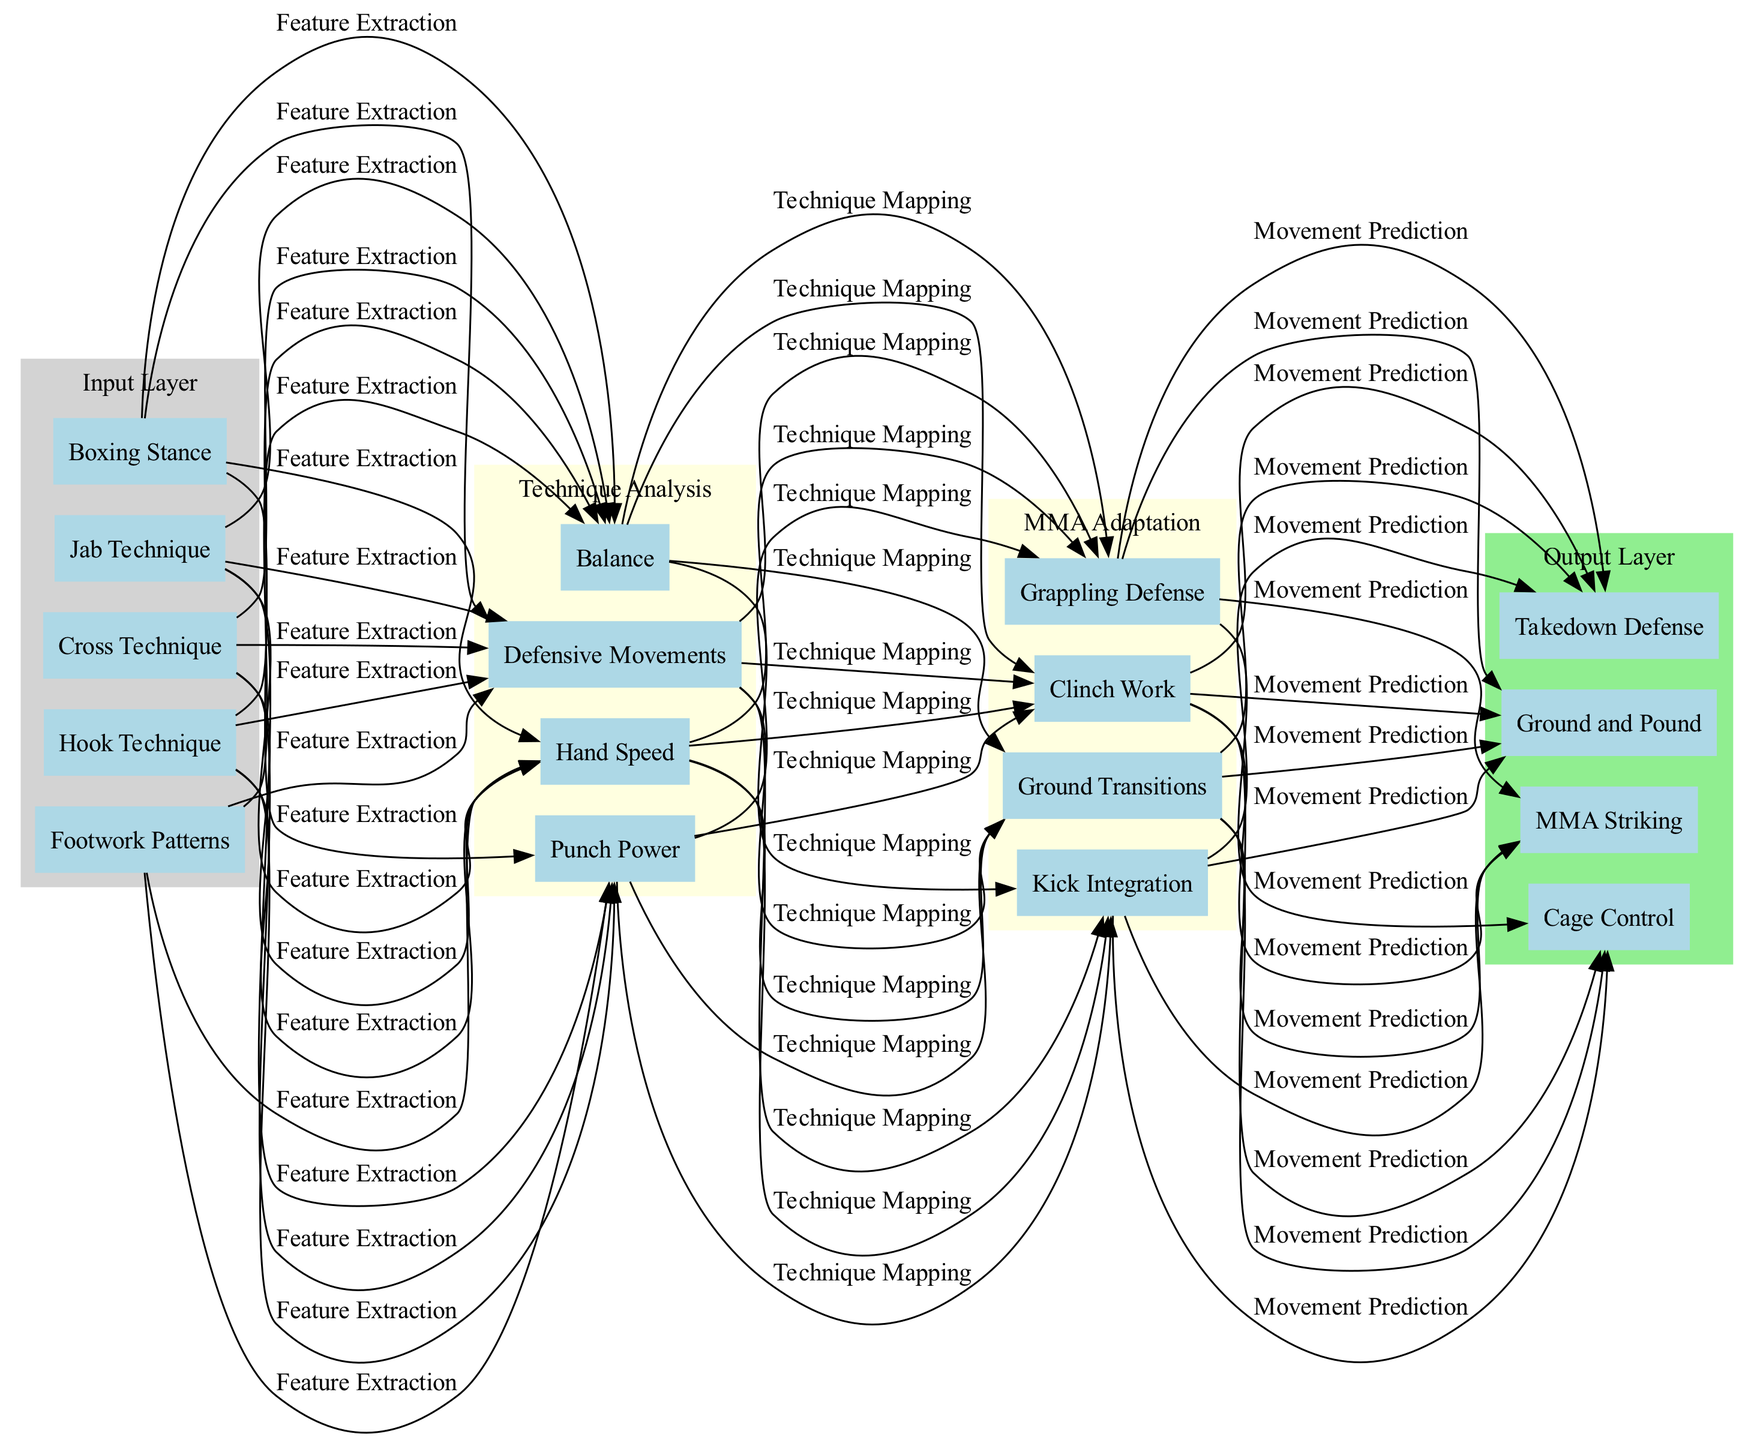What are the inputs of this neural network? The input layer contains nodes representing specific boxing techniques and stances. By observing the input layer in the diagram, we can see the following nodes: Boxing Stance, Jab Technique, Cross Technique, Hook Technique, and Footwork Patterns.
Answer: Boxing Stance, Jab Technique, Cross Technique, Hook Technique, Footwork Patterns How many nodes are in the hidden layers? There are a total of 8 nodes in the hidden layers. The first hidden layer has 4 nodes (Punch Power, Hand Speed, Balance, Defensive Movements) and the second hidden layer has 4 nodes (Grappling Defense, Kick Integration, Clinch Work, Ground Transitions). Adding these together gives us 4 + 4 = 8.
Answer: 8 What is the output of the neural network? The output layer consists of four nodes that represent the final outcomes of the neural network's processing, namely MMA Striking, Takedown Defense, Cage Control, and Ground and Pound, which can be seen directly in the output layer of the diagram.
Answer: MMA Striking, Takedown Defense, Cage Control, Ground and Pound What is the purpose of the "Technique Analysis" layer? The "Technique Analysis" hidden layer processes input such as boxing techniques to assess various attributes. It consists of nodes that analyze Punch Power, Hand Speed, Balance, and Defensive Movements, which are essential for understanding how boxing techniques can be broken down into measurable qualities.
Answer: Analyze boxing techniques How do the input nodes connect to the hidden layers? Each input node connects to all nodes in the first hidden layer. The connections represent the processing of the boxing techniques in the first hidden layer. Since the diagram indicates that all input nodes link to the Punch Power, Hand Speed, Balance, and Defensive Movements nodes, we can deduce that the input layer influences multiple aspects of the first hidden layer's analysis.
Answer: All input nodes connect Which hidden layer focuses on MMA adaptation? The second hidden layer, labeled "MMA Adaptation," specifically addresses the translation of boxing techniques into MMA skills. It includes nodes such as Grappling Defense, Kick Integration, Clinch Work, and Ground Transitions, showcasing its focus on adapting boxing skills for mixed martial arts contexts.
Answer: MMA Adaptation Which connection indicates 'Movement Prediction'? The 'Movement Prediction' connection is implied to occur between the first hidden layer and the output layer, as the process requires analyzing movement patterns resultant from the boxing techniques to predict effective MMA maneuvers. Consequently, when examining edges from the first hidden layer to the output, we see that this connection likely corresponds to how the input translates into movements for MMA.
Answer: Between first hidden layer and output layer How many connections are indicated in the diagram? The diagram indicates four connections listed: Feature Extraction, Technique Mapping, Movement Prediction, and Strategy Optimization. By counting these expressly stated connections, we verify a total of four links woven throughout the model.
Answer: 4 